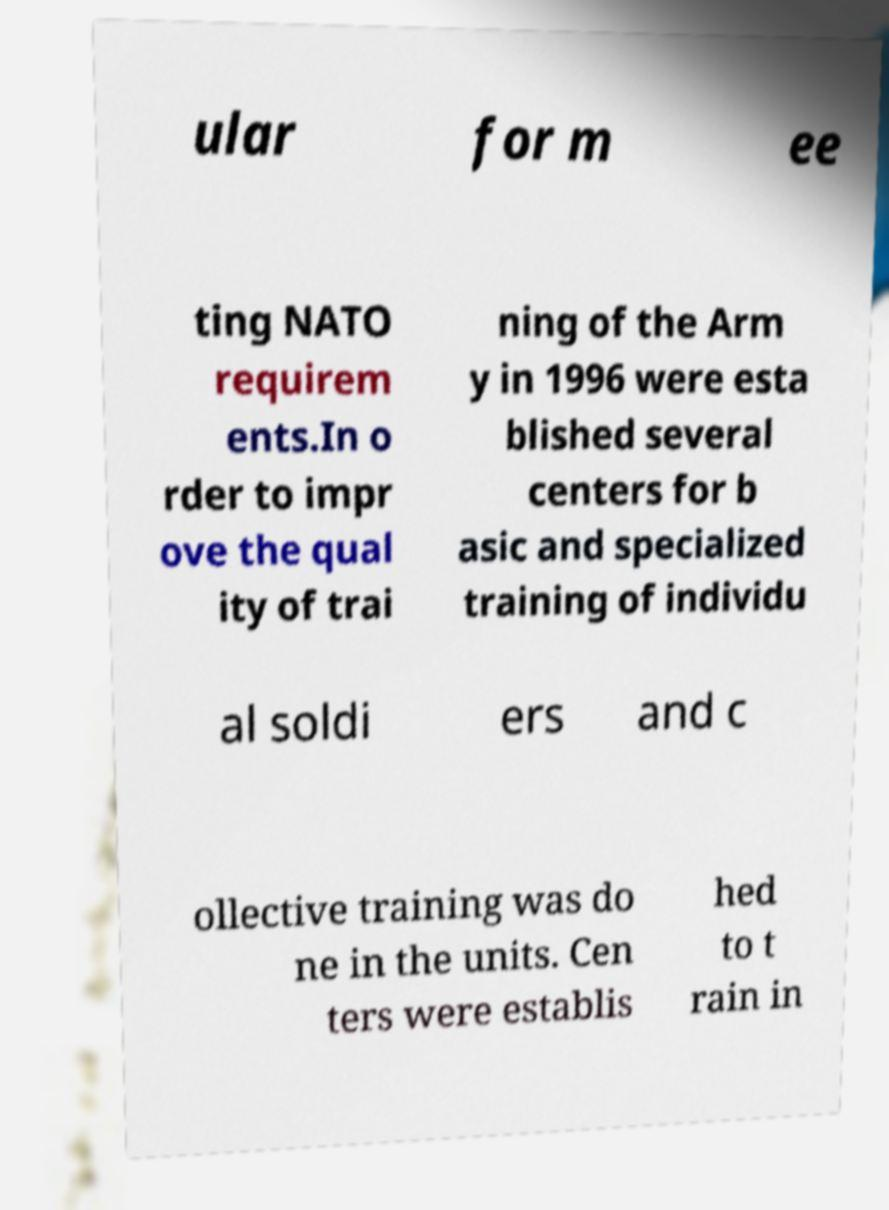I need the written content from this picture converted into text. Can you do that? ular for m ee ting NATO requirem ents.In o rder to impr ove the qual ity of trai ning of the Arm y in 1996 were esta blished several centers for b asic and specialized training of individu al soldi ers and c ollective training was do ne in the units. Cen ters were establis hed to t rain in 